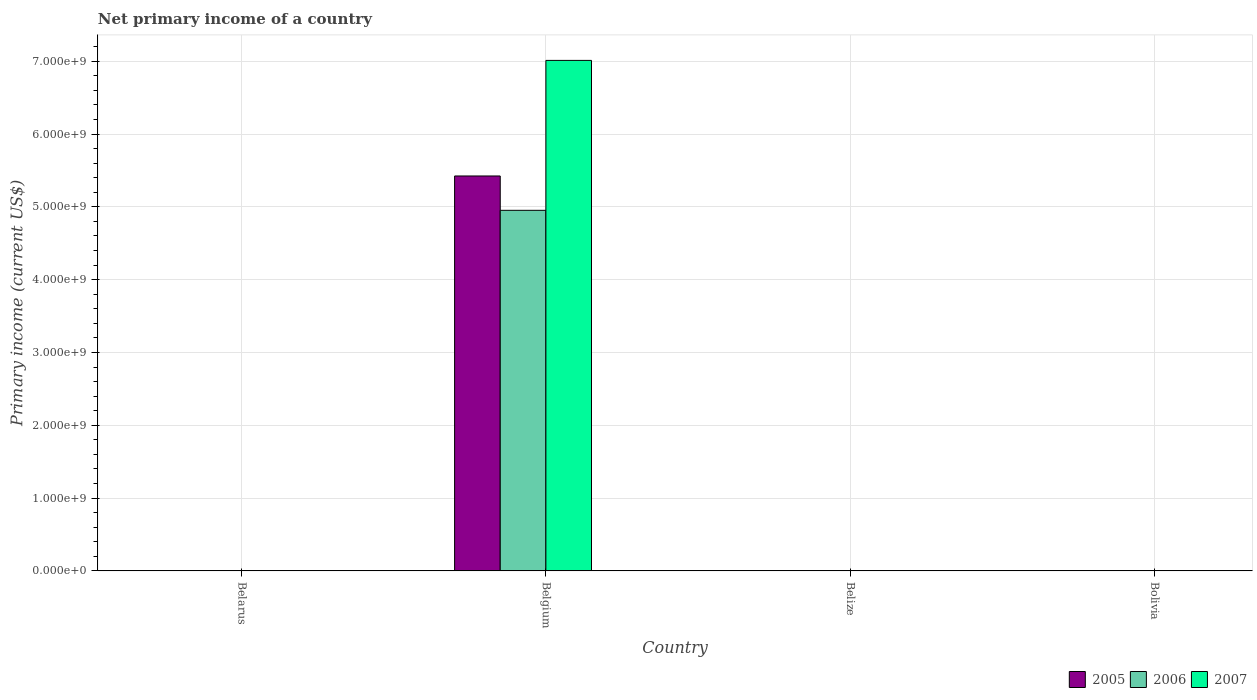Are the number of bars per tick equal to the number of legend labels?
Offer a very short reply. No. How many bars are there on the 2nd tick from the left?
Offer a very short reply. 3. How many bars are there on the 1st tick from the right?
Offer a terse response. 0. In how many cases, is the number of bars for a given country not equal to the number of legend labels?
Your response must be concise. 3. What is the primary income in 2007 in Belgium?
Your response must be concise. 7.01e+09. Across all countries, what is the maximum primary income in 2006?
Ensure brevity in your answer.  4.95e+09. Across all countries, what is the minimum primary income in 2005?
Your answer should be compact. 0. What is the total primary income in 2005 in the graph?
Provide a short and direct response. 5.42e+09. What is the difference between the primary income in 2005 in Belize and the primary income in 2007 in Bolivia?
Make the answer very short. 0. What is the average primary income in 2007 per country?
Give a very brief answer. 1.75e+09. What is the difference between the primary income of/in 2006 and primary income of/in 2007 in Belgium?
Your answer should be very brief. -2.06e+09. In how many countries, is the primary income in 2005 greater than 2200000000 US$?
Your answer should be very brief. 1. What is the difference between the highest and the lowest primary income in 2005?
Make the answer very short. 5.42e+09. In how many countries, is the primary income in 2006 greater than the average primary income in 2006 taken over all countries?
Give a very brief answer. 1. Is it the case that in every country, the sum of the primary income in 2006 and primary income in 2005 is greater than the primary income in 2007?
Ensure brevity in your answer.  No. Are all the bars in the graph horizontal?
Offer a terse response. No. How many countries are there in the graph?
Offer a very short reply. 4. Are the values on the major ticks of Y-axis written in scientific E-notation?
Keep it short and to the point. Yes. Does the graph contain any zero values?
Ensure brevity in your answer.  Yes. Where does the legend appear in the graph?
Offer a terse response. Bottom right. How many legend labels are there?
Make the answer very short. 3. What is the title of the graph?
Provide a succinct answer. Net primary income of a country. What is the label or title of the Y-axis?
Provide a succinct answer. Primary income (current US$). What is the Primary income (current US$) of 2006 in Belarus?
Give a very brief answer. 0. What is the Primary income (current US$) of 2007 in Belarus?
Your answer should be compact. 0. What is the Primary income (current US$) in 2005 in Belgium?
Make the answer very short. 5.42e+09. What is the Primary income (current US$) in 2006 in Belgium?
Make the answer very short. 4.95e+09. What is the Primary income (current US$) of 2007 in Belgium?
Offer a terse response. 7.01e+09. What is the Primary income (current US$) of 2006 in Belize?
Offer a terse response. 0. What is the Primary income (current US$) of 2005 in Bolivia?
Give a very brief answer. 0. What is the Primary income (current US$) in 2006 in Bolivia?
Your answer should be compact. 0. What is the Primary income (current US$) in 2007 in Bolivia?
Keep it short and to the point. 0. Across all countries, what is the maximum Primary income (current US$) of 2005?
Provide a short and direct response. 5.42e+09. Across all countries, what is the maximum Primary income (current US$) in 2006?
Offer a terse response. 4.95e+09. Across all countries, what is the maximum Primary income (current US$) in 2007?
Keep it short and to the point. 7.01e+09. Across all countries, what is the minimum Primary income (current US$) in 2005?
Offer a terse response. 0. Across all countries, what is the minimum Primary income (current US$) in 2006?
Give a very brief answer. 0. Across all countries, what is the minimum Primary income (current US$) of 2007?
Your answer should be very brief. 0. What is the total Primary income (current US$) of 2005 in the graph?
Offer a very short reply. 5.42e+09. What is the total Primary income (current US$) of 2006 in the graph?
Ensure brevity in your answer.  4.95e+09. What is the total Primary income (current US$) of 2007 in the graph?
Offer a very short reply. 7.01e+09. What is the average Primary income (current US$) of 2005 per country?
Give a very brief answer. 1.36e+09. What is the average Primary income (current US$) of 2006 per country?
Give a very brief answer. 1.24e+09. What is the average Primary income (current US$) of 2007 per country?
Your response must be concise. 1.75e+09. What is the difference between the Primary income (current US$) in 2005 and Primary income (current US$) in 2006 in Belgium?
Keep it short and to the point. 4.72e+08. What is the difference between the Primary income (current US$) in 2005 and Primary income (current US$) in 2007 in Belgium?
Your response must be concise. -1.59e+09. What is the difference between the Primary income (current US$) of 2006 and Primary income (current US$) of 2007 in Belgium?
Offer a terse response. -2.06e+09. What is the difference between the highest and the lowest Primary income (current US$) in 2005?
Your response must be concise. 5.42e+09. What is the difference between the highest and the lowest Primary income (current US$) in 2006?
Offer a very short reply. 4.95e+09. What is the difference between the highest and the lowest Primary income (current US$) of 2007?
Offer a terse response. 7.01e+09. 